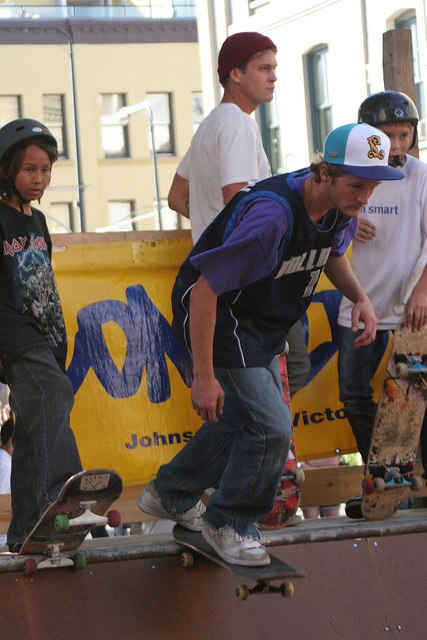Describe the objects in this image and their specific colors. I can see people in beige, black, gray, navy, and maroon tones, people in beige, black, gray, maroon, and brown tones, people in beige, darkgray, black, and gray tones, people in beige, darkgray, brown, lightgray, and maroon tones, and skateboard in beige, maroon, gray, and black tones in this image. 